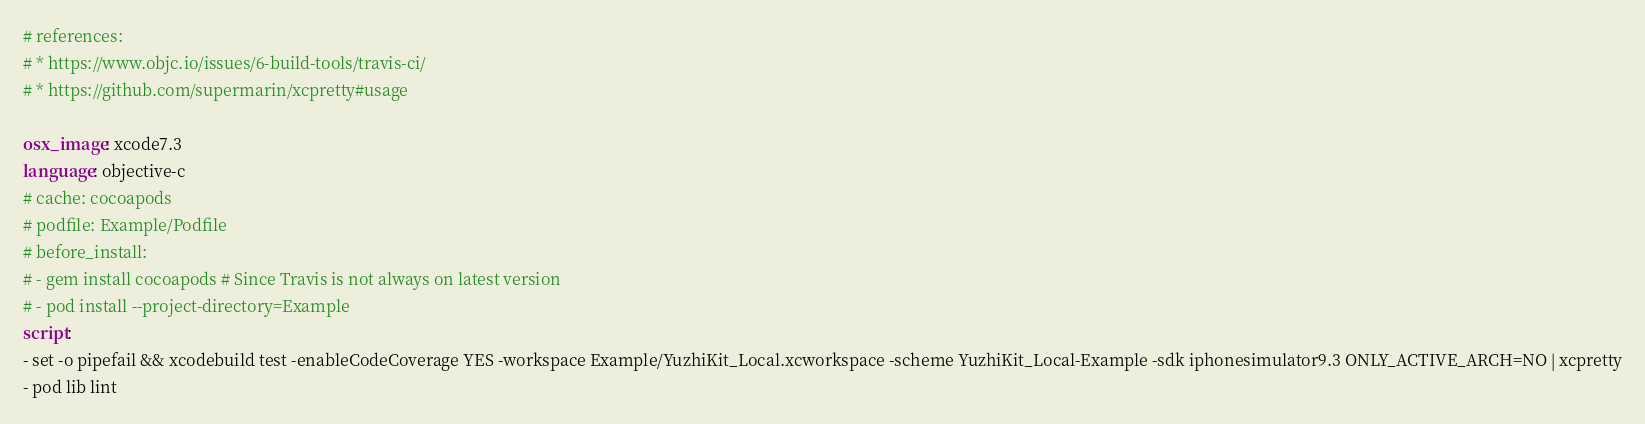Convert code to text. <code><loc_0><loc_0><loc_500><loc_500><_YAML_># references:
# * https://www.objc.io/issues/6-build-tools/travis-ci/
# * https://github.com/supermarin/xcpretty#usage

osx_image: xcode7.3
language: objective-c
# cache: cocoapods
# podfile: Example/Podfile
# before_install:
# - gem install cocoapods # Since Travis is not always on latest version
# - pod install --project-directory=Example
script:
- set -o pipefail && xcodebuild test -enableCodeCoverage YES -workspace Example/YuzhiKit_Local.xcworkspace -scheme YuzhiKit_Local-Example -sdk iphonesimulator9.3 ONLY_ACTIVE_ARCH=NO | xcpretty
- pod lib lint
</code> 